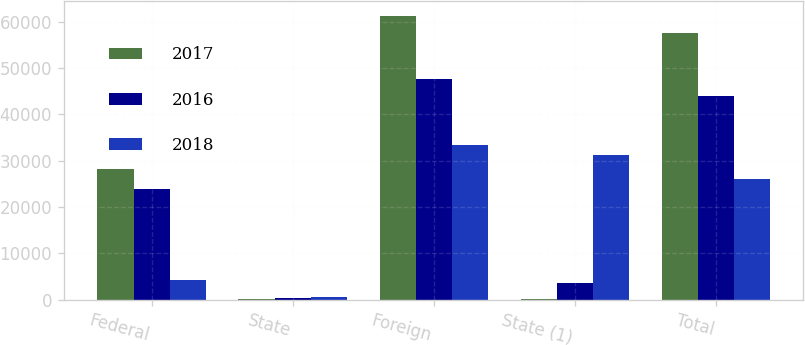Convert chart. <chart><loc_0><loc_0><loc_500><loc_500><stacked_bar_chart><ecel><fcel>Federal<fcel>State<fcel>Foreign<fcel>State (1)<fcel>Total<nl><fcel>2017<fcel>28168<fcel>229<fcel>61284<fcel>253<fcel>57433<nl><fcel>2016<fcel>23835<fcel>476<fcel>47579<fcel>3659<fcel>43863<nl><fcel>2018<fcel>4285<fcel>541<fcel>33346<fcel>31229<fcel>25983<nl></chart> 